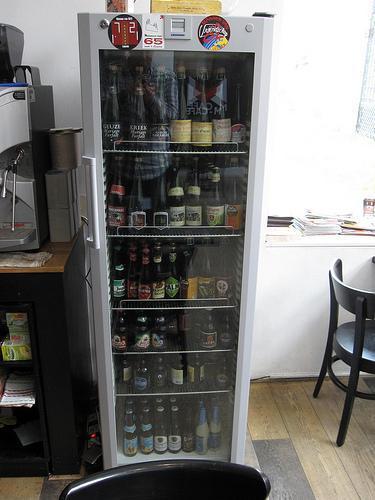How many people are visible?
Give a very brief answer. 0. 